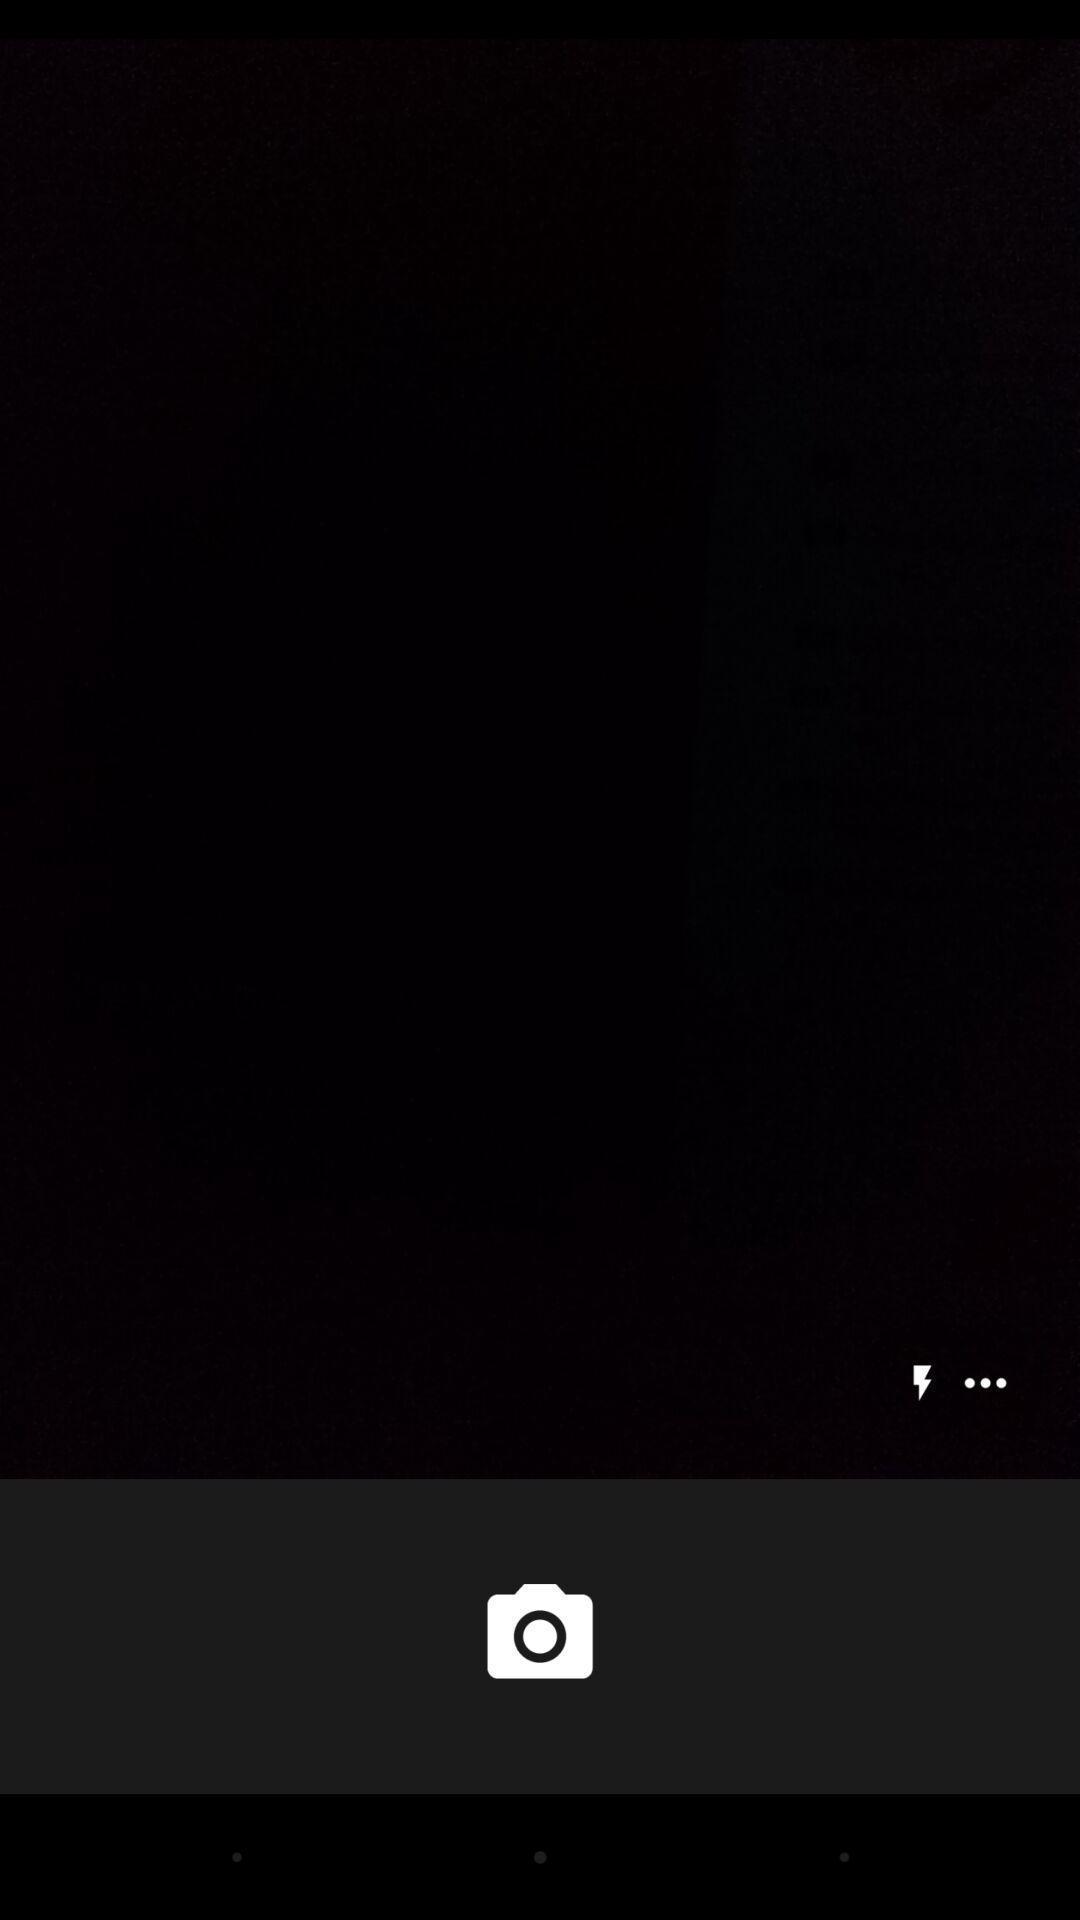Explain what's happening in this screen capture. Page shows to take the dark photo. 